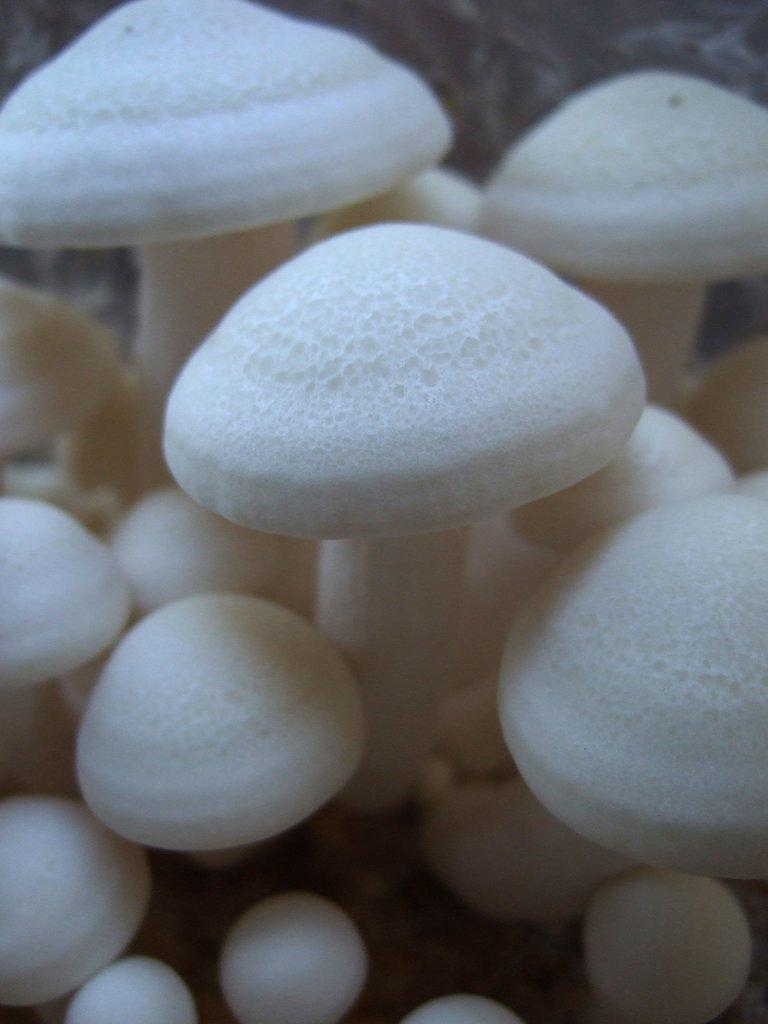What type of fungi can be seen in the image? There are white mushrooms in the image. What hobbies do the mushrooms enjoy in the image? There is no information about the mushrooms' hobbies in the image, as mushrooms do not have hobbies. 